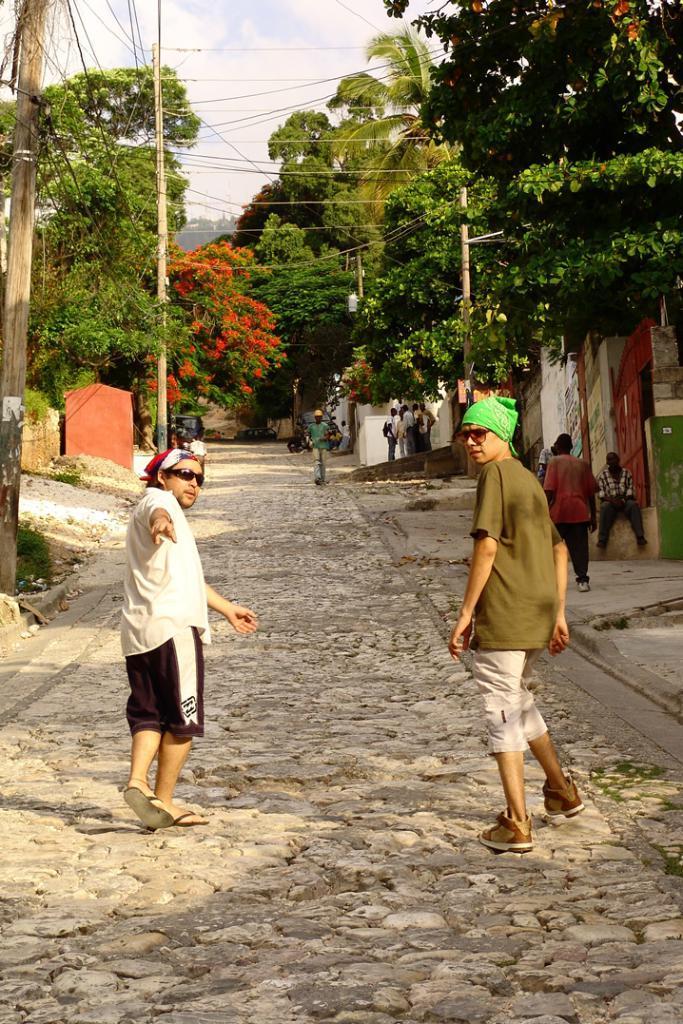Can you describe this image briefly? In this image, there are a few people. We can see the ground with some rocks and objects. We can also see a few poles with wires. We can see some trees and the wall. We can also see the sky. 